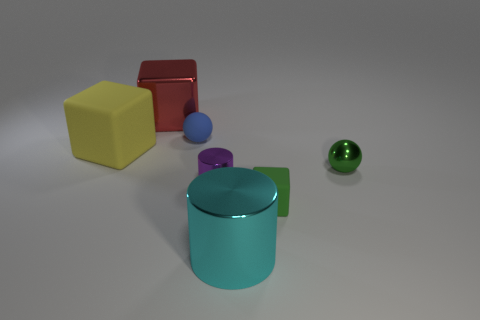Add 3 tiny shiny things. How many objects exist? 10 Subtract all blocks. How many objects are left? 4 Add 4 small green shiny cylinders. How many small green shiny cylinders exist? 4 Subtract 1 green balls. How many objects are left? 6 Subtract all tiny blue objects. Subtract all purple metal cylinders. How many objects are left? 5 Add 4 small purple shiny cylinders. How many small purple shiny cylinders are left? 5 